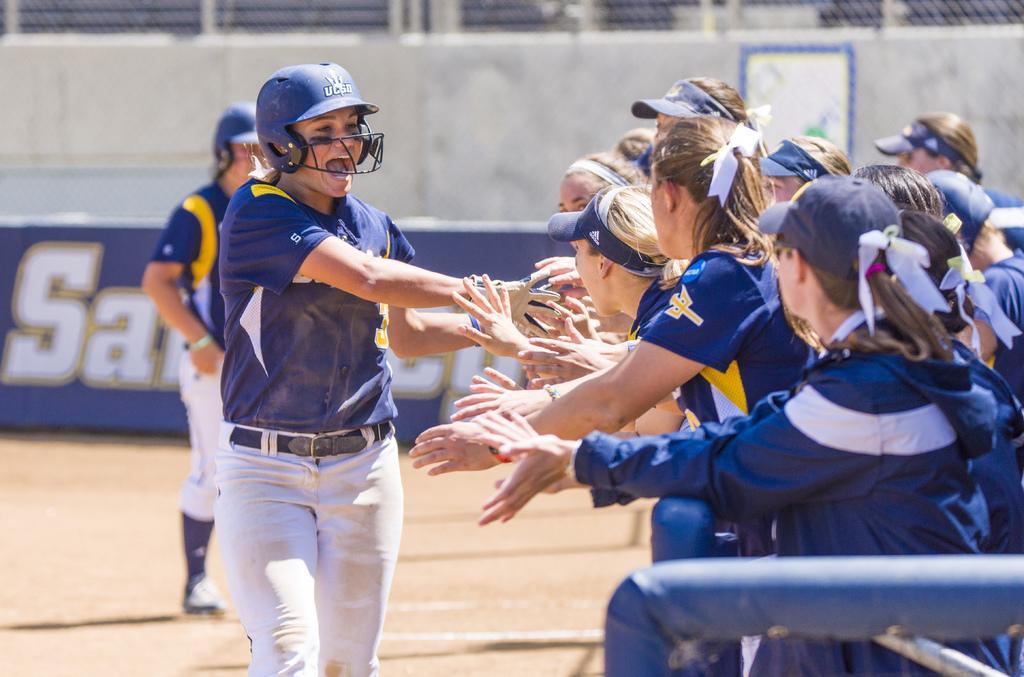Could you give a brief overview of what you see in this image? Here we can see persons on the ground. In the background we can see a hoarding and a wall. 